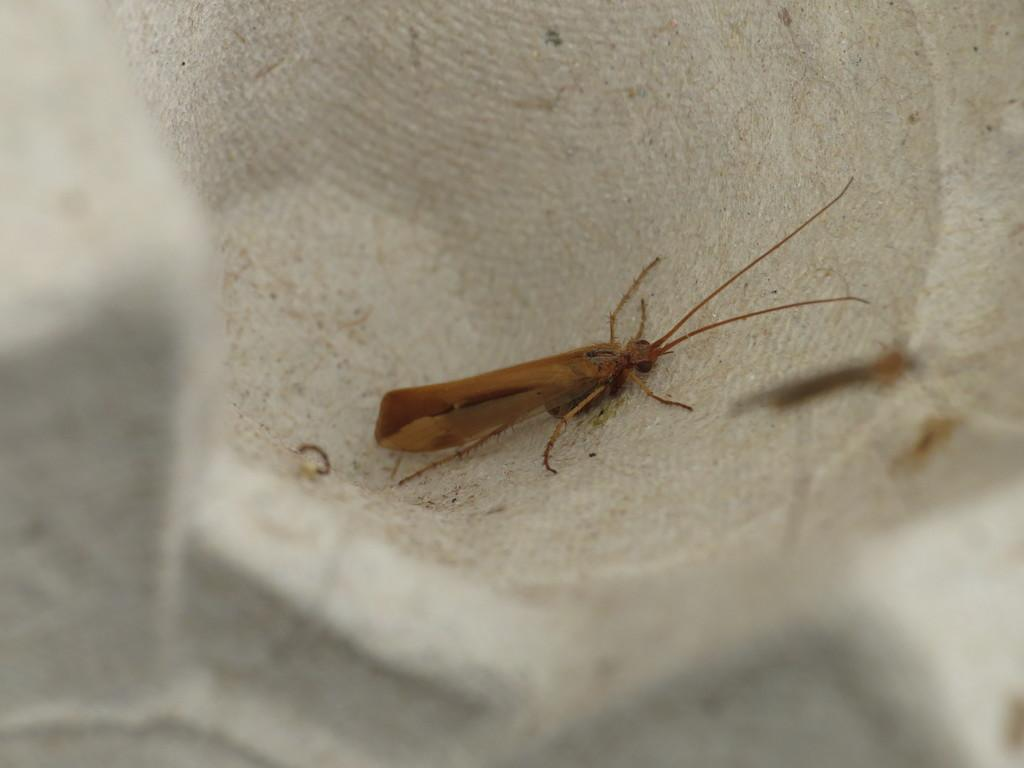What type of creature can be seen in the image? There is an insect in the image. What is the background or surface on which the insect is located? The insect is on a white surface. What type of news can be seen being read by the insect in the image? There is no news or any indication of reading in the image; it features an insect on a white surface. 